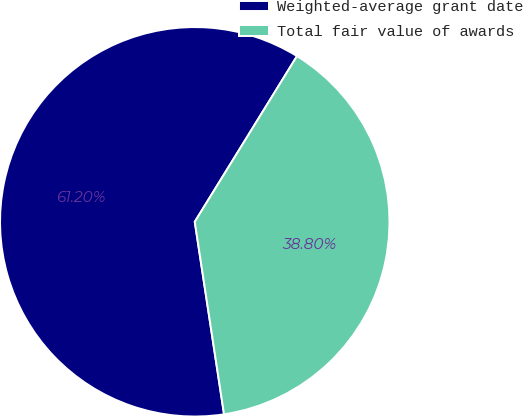Convert chart. <chart><loc_0><loc_0><loc_500><loc_500><pie_chart><fcel>Weighted-average grant date<fcel>Total fair value of awards<nl><fcel>61.2%<fcel>38.8%<nl></chart> 